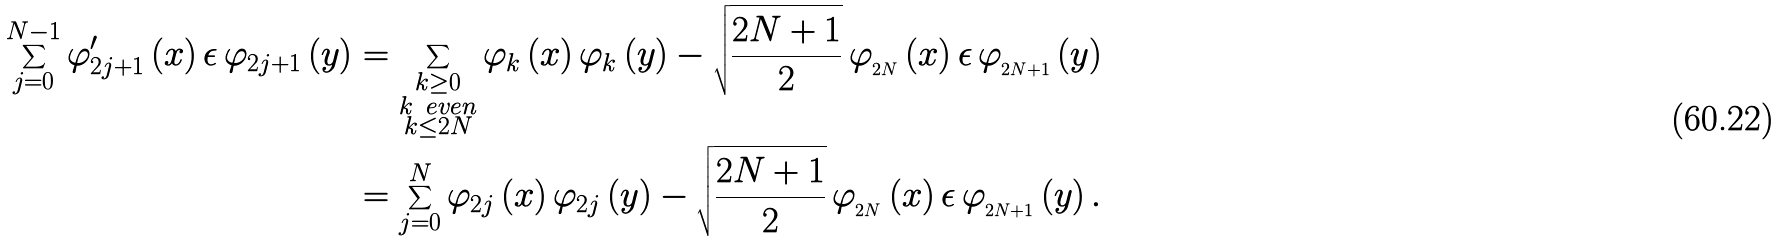Convert formula to latex. <formula><loc_0><loc_0><loc_500><loc_500>\sum _ { j = 0 } ^ { N - 1 } \varphi _ { 2 j + 1 } ^ { \prime } \left ( x \right ) \epsilon \, \varphi _ { 2 j + 1 } \left ( y \right ) & = \sum _ { \substack { k \geq 0 \\ k \ e v e n \\ k \leq 2 N } } \varphi _ { k } \left ( x \right ) \varphi _ { k } \left ( y \right ) - \sqrt { \frac { 2 N + 1 } { 2 } } \, \varphi _ { _ { 2 N } } \left ( x \right ) \epsilon \, \varphi _ { _ { 2 N + 1 } } \left ( y \right ) \\ & = \sum _ { j = 0 } ^ { N } \varphi _ { 2 j } \left ( x \right ) \varphi _ { 2 j } \left ( y \right ) - \sqrt { \frac { 2 N + 1 } { 2 } } \, \varphi _ { _ { 2 N } } \left ( x \right ) \epsilon \, \varphi _ { _ { 2 N + 1 } } \left ( y \right ) .</formula> 